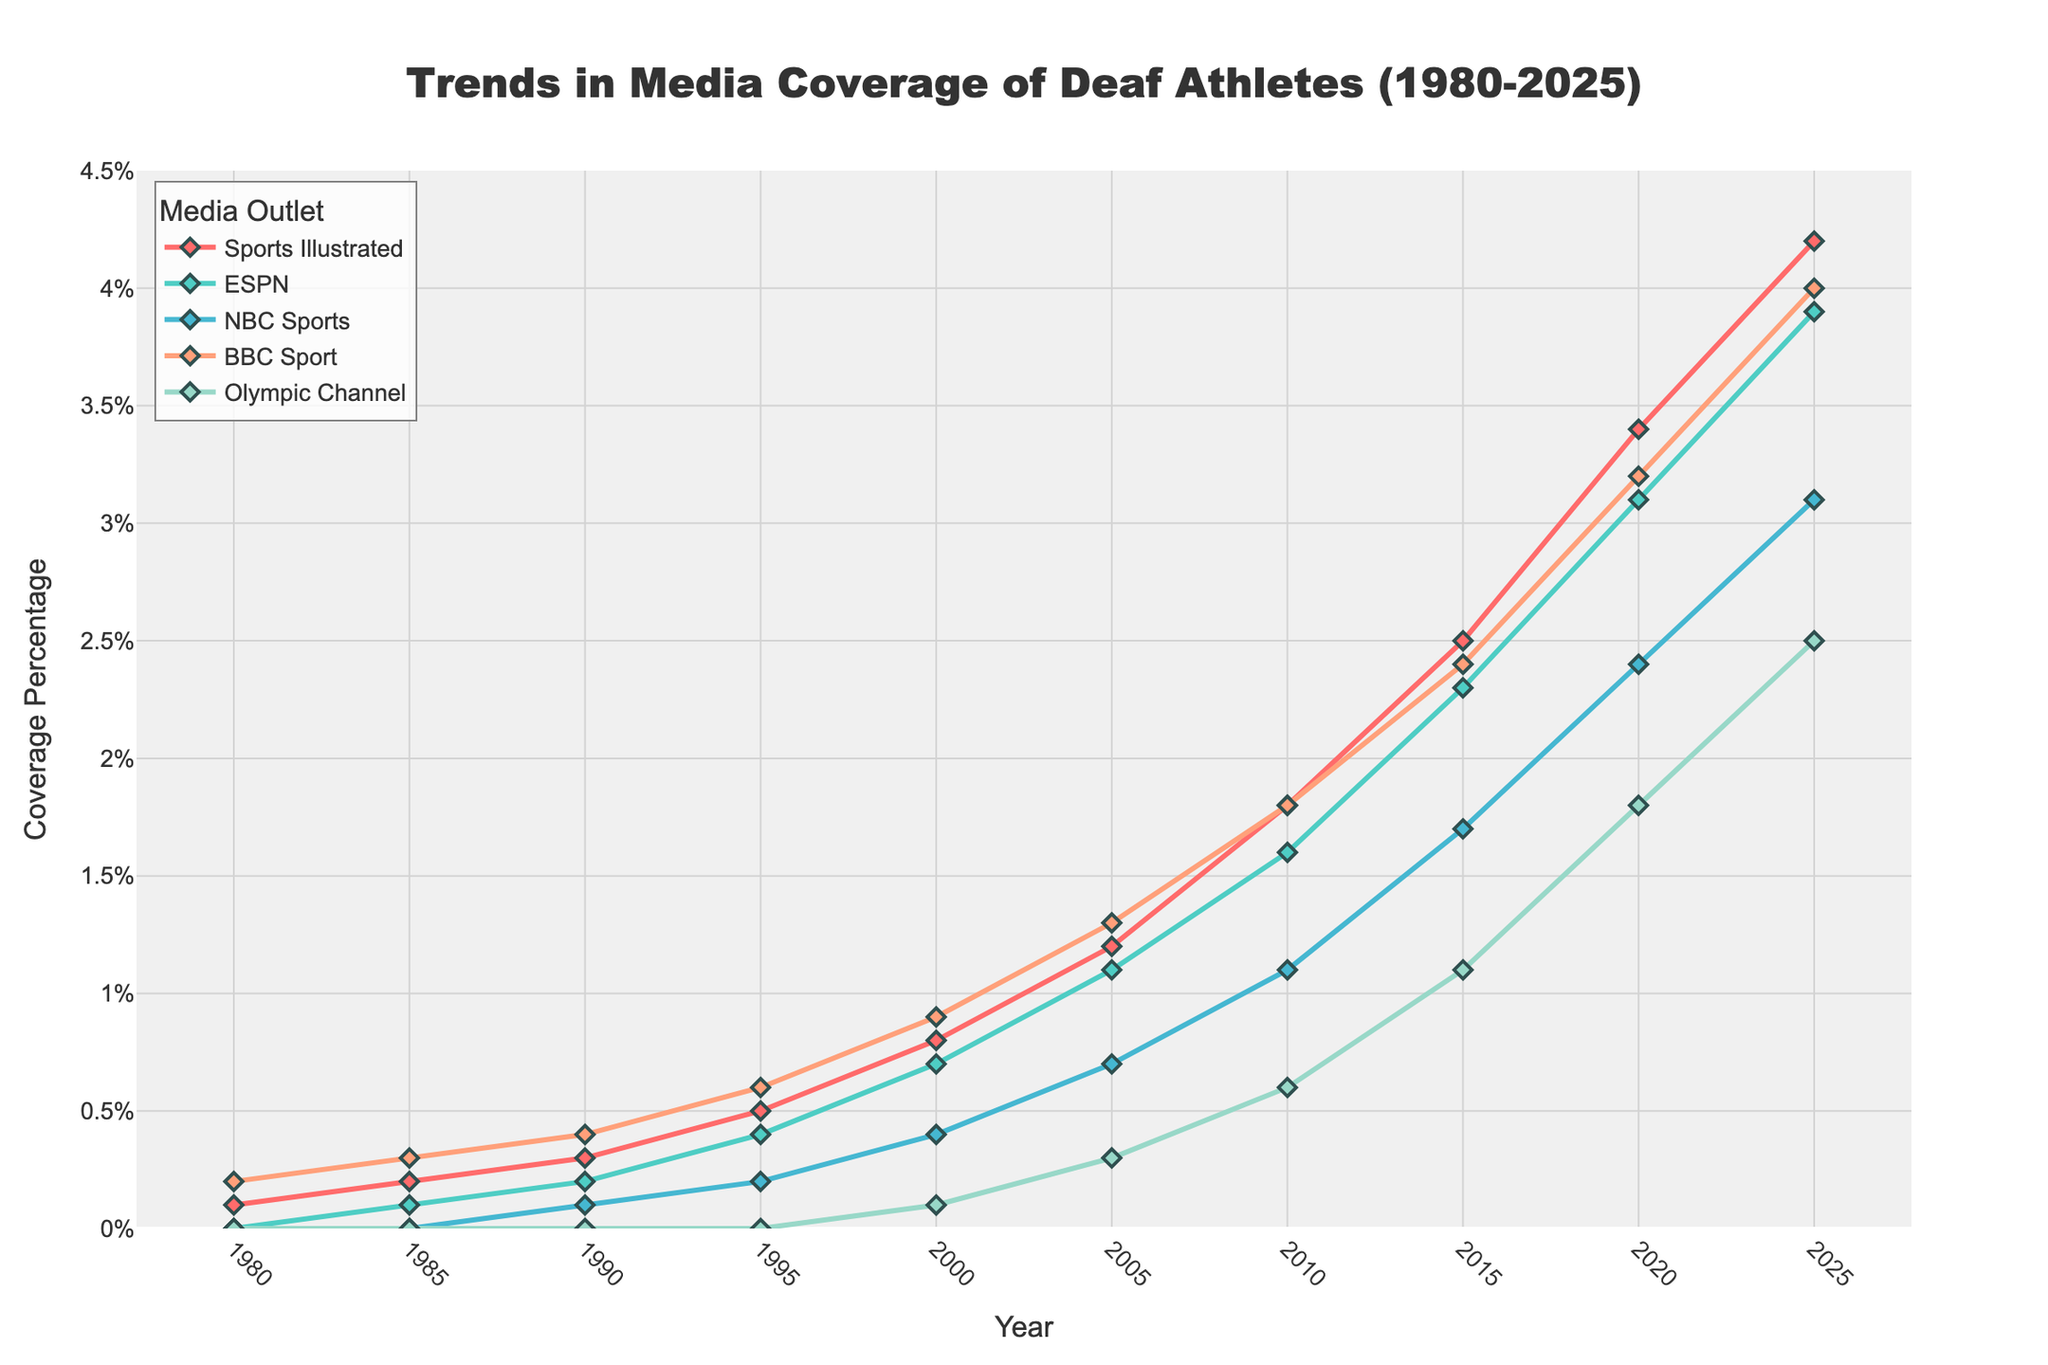What is the trend in media coverage of Deaf athletes for Sports Illustrated from 1980 to 2025? The line for Sports Illustrated starts at 0.1% in 1980 and increases steadily to 4.2% by 2025. The trend shows a continuous upward trajectory for Sports Illustrated over the given period.
Answer: Increasing Which media outlet had the highest coverage percentage in 2025? By examining the line chart at the year 2025, BBC Sport has the highest coverage percentage at 4.0%.
Answer: BBC Sport In which year does the Olympic Channel begin to show coverage of Deaf athletes? The Olympic Channel first shows a non-zero value in the year 2000, indicating it started covering Deaf athletes then.
Answer: 2000 By how many percentage points did ESPN’s coverage increase from 1985 to 2010? In 1985, ESPN's coverage was at 0.1%, and in 2010, it was at 1.6%. The increase is 1.6% - 0.1% = 1.5 percentage points.
Answer: 1.5 Which years show the same percentage of coverage for NBC Sports and Olympic Channel? By inspecting the lines for NBC Sports and Olympic Channel, they intersect at no point, indicating that they do not show the same percentage in any given year.
Answer: None Compare the overall trend of BBC Sport and NBC Sports from 1990 to 2020. BBC Sport’s trend shows a consistent increase from 0.4% in 1990 to 3.2% in 2020. On the other hand, NBC Sports shows a slower and lower increase, starting at 0.1% in 1990 and reaching 2.4% in 2020. BBC Sport generally shows a steeper increase.
Answer: BBC Sport increases significantly faster Which media outlet has the most gradual increase in coverage from 1980 to 2025? By analyzing the slopes of the lines, the Olympic Channel shows the most gradual increase, beginning at 0% in 1980 and reaching just 2.5% by 2025.
Answer: Olympic Channel What was the coverage percentage for Deaf athletes by NBC Sports in the year 2000? By looking at the chart for the year 2000, the coverage percentage of Deaf athletes by NBC Sports is at 0.4%.
Answer: 0.4 Calculate the average yearly increase in coverage percentage for Sports Illustrated from 1980 to 2025. The increase from 0.1% in 1980 to 4.2% in 2025 over 45 years is 4.1 percentage points. The average yearly increase is 4.1 / 45 ≈ 0.091.
Answer: 0.091 